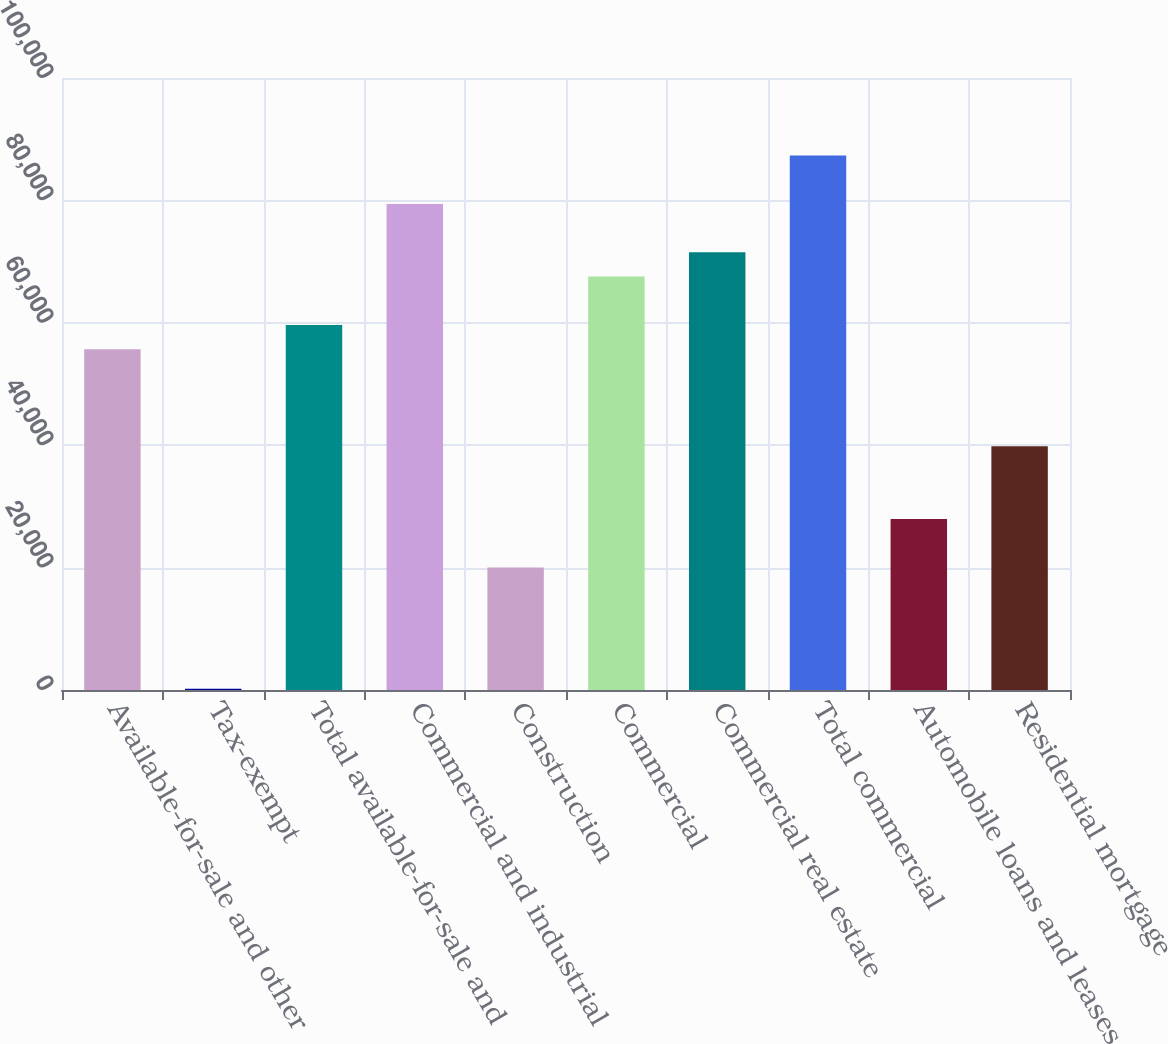Convert chart to OTSL. <chart><loc_0><loc_0><loc_500><loc_500><bar_chart><fcel>Available-for-sale and other<fcel>Tax-exempt<fcel>Total available-for-sale and<fcel>Commercial and industrial<fcel>Construction<fcel>Commercial<fcel>Commercial real estate<fcel>Total commercial<fcel>Automobile loans and leases<fcel>Residential mortgage<nl><fcel>55665.2<fcel>214<fcel>59626<fcel>79430<fcel>20018<fcel>67547.6<fcel>71508.4<fcel>87351.6<fcel>27939.6<fcel>39822<nl></chart> 